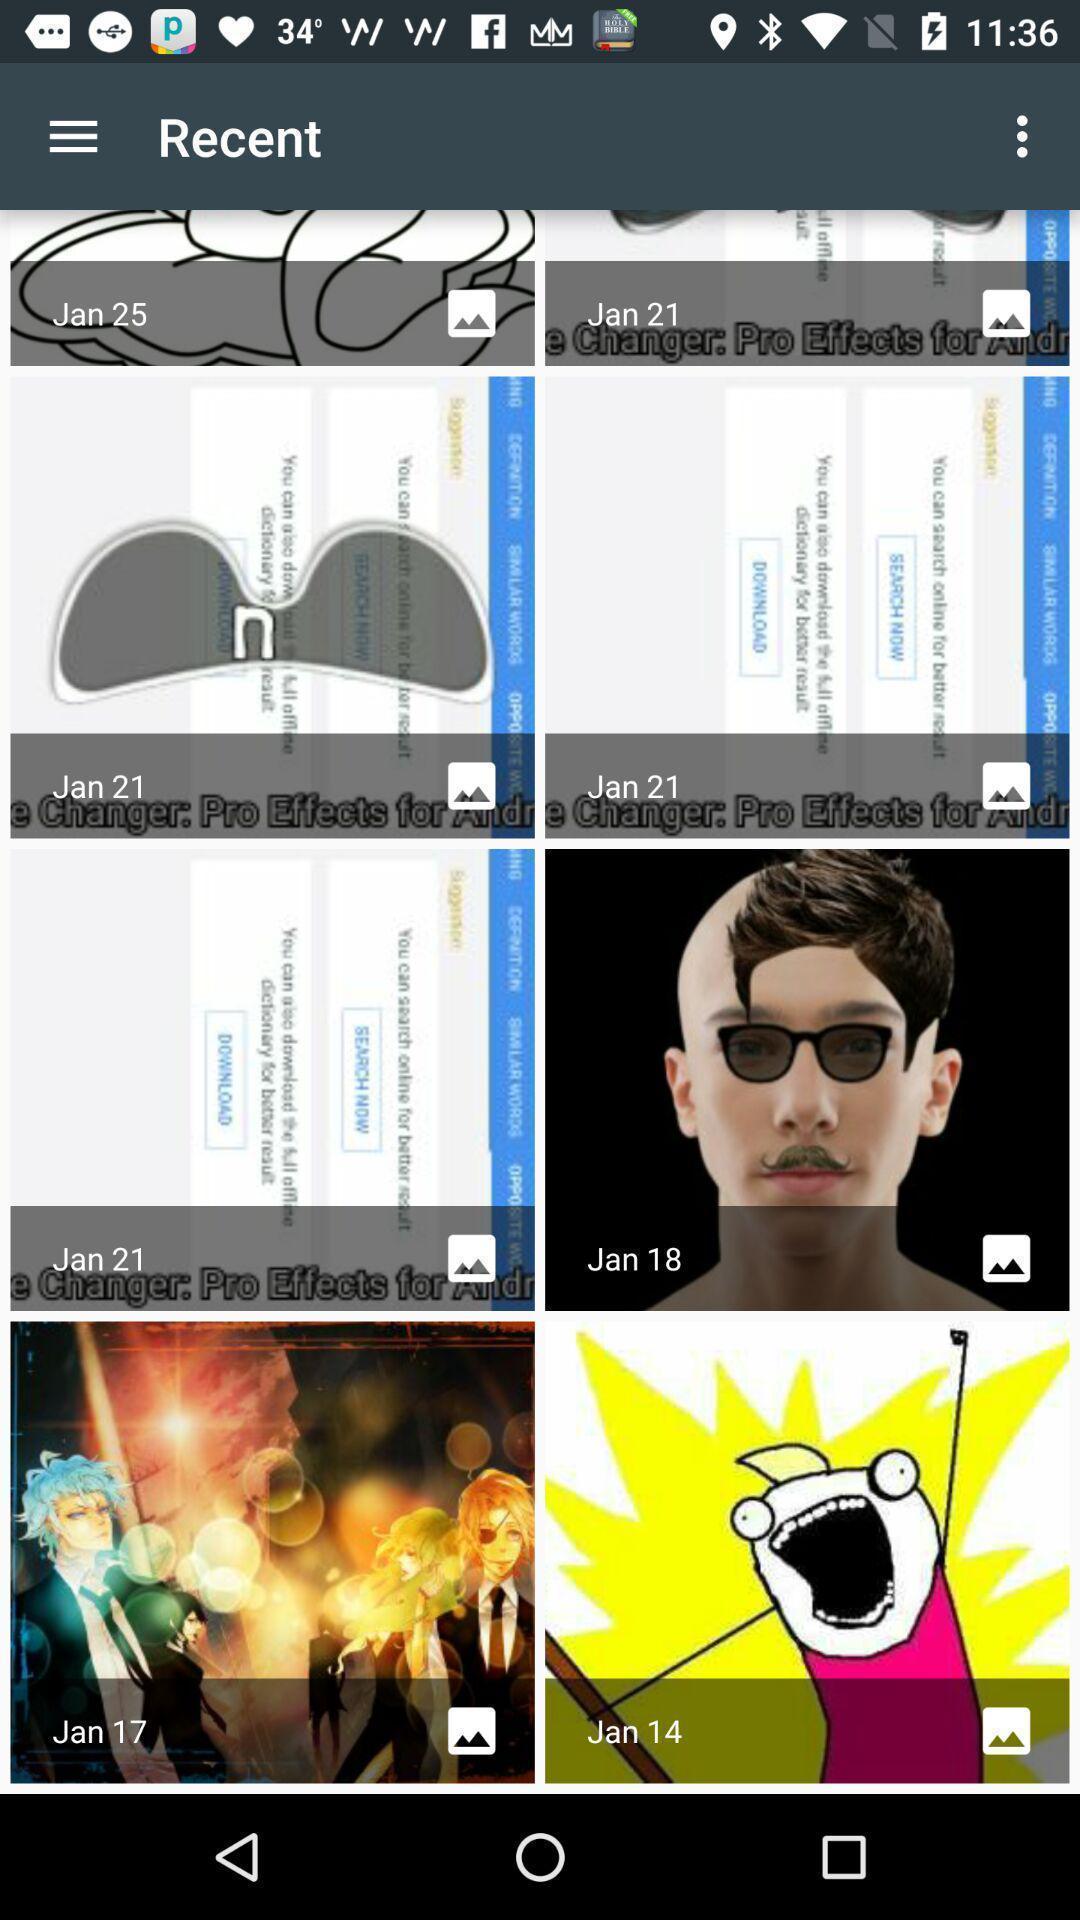Summarize the information in this screenshot. Screen shows about recent images in a gallery. 